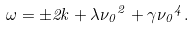<formula> <loc_0><loc_0><loc_500><loc_500>\omega = \pm 2 k + \lambda { \nu _ { 0 } } ^ { 2 } + \gamma { \nu _ { 0 } } ^ { 4 } .</formula> 